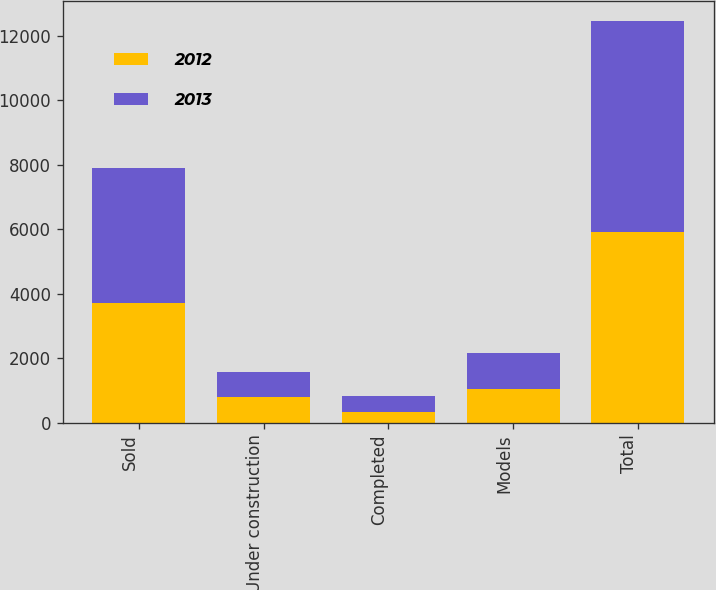Convert chart to OTSL. <chart><loc_0><loc_0><loc_500><loc_500><stacked_bar_chart><ecel><fcel>Sold<fcel>Under construction<fcel>Completed<fcel>Models<fcel>Total<nl><fcel>2012<fcel>3723<fcel>813<fcel>338<fcel>1034<fcel>5908<nl><fcel>2013<fcel>4162<fcel>753<fcel>503<fcel>1119<fcel>6537<nl></chart> 